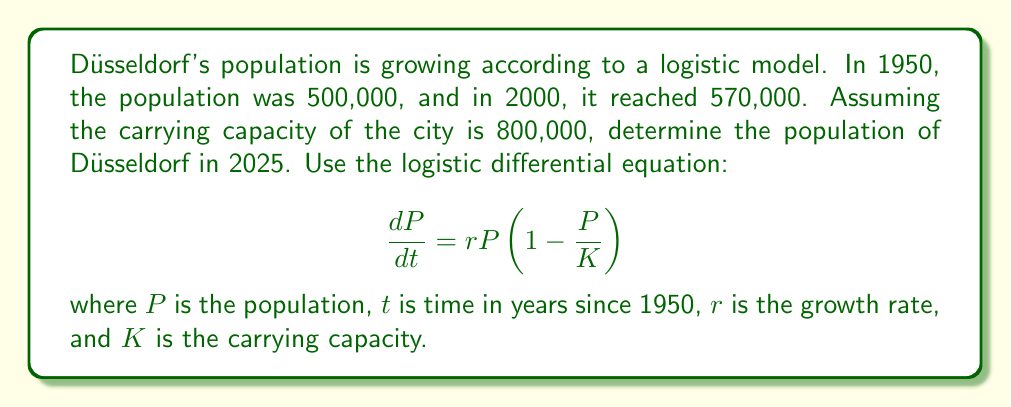Solve this math problem. Let's approach this step-by-step:

1) The logistic equation solution is:

   $$P(t) = \frac{K}{1 + Ae^{-rt}}$$

   where $A = \frac{K-P_0}{P_0}$, and $P_0$ is the initial population.

2) We know:
   - $K = 800,000$
   - $P_0 = 500,000$ (in 1950, $t=0$)
   - $P(50) = 570,000$ (in 2000, $t=50$)

3) First, let's calculate $A$:
   
   $$A = \frac{800,000 - 500,000}{500,000} = 0.6$$

4) Now, we can use the second data point to find $r$:

   $$570,000 = \frac{800,000}{1 + 0.6e^{-50r}}$$

5) Solving for $r$:

   $$1 + 0.6e^{-50r} = \frac{800,000}{570,000}$$
   $$0.6e^{-50r} = \frac{800,000}{570,000} - 1 = 0.4035$$
   $$e^{-50r} = 0.6725$$
   $$-50r = \ln(0.6725)$$
   $$r = -\frac{\ln(0.6725)}{50} = 0.00794$$

6) Now we have all parameters. For 2025, $t = 75$ (75 years after 1950).

7) Let's substitute into the logistic equation:

   $$P(75) = \frac{800,000}{1 + 0.6e^{-0.00794 * 75}}$$

8) Calculating this gives us the population in 2025.
Answer: The population of Düsseldorf in 2025 will be approximately 611,000 people. 